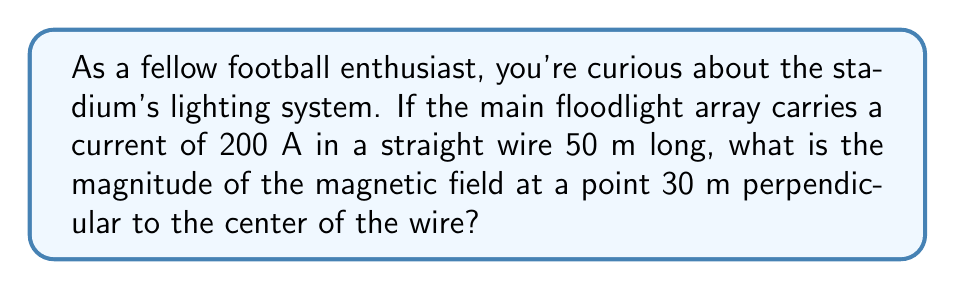What is the answer to this math problem? Let's approach this step-by-step using the Biot-Savart law:

1) The Biot-Savart law for a long straight wire is:

   $$B = \frac{\mu_0 I}{2\pi r}$$

   Where:
   - $B$ is the magnetic field strength
   - $\mu_0$ is the permeability of free space ($4\pi \times 10^{-7}$ T⋅m/A)
   - $I$ is the current
   - $r$ is the perpendicular distance from the wire

2) We're given:
   - $I = 200$ A
   - $r = 30$ m

3) Substituting these values:

   $$B = \frac{(4\pi \times 10^{-7})(200)}{2\pi(30)}$$

4) Simplify:

   $$B = \frac{4\pi \times 10^{-7} \times 200}{2\pi \times 30} = \frac{8 \times 10^{-5}}{30}$$

5) Calculate:

   $$B = 2.67 \times 10^{-6}$$ T

6) Convert to nanotesla (nT) for a more practical unit:

   $$B = 2.67 \times 10^{-6} \times 10^9 = 2670$$ nT
Answer: 2670 nT 